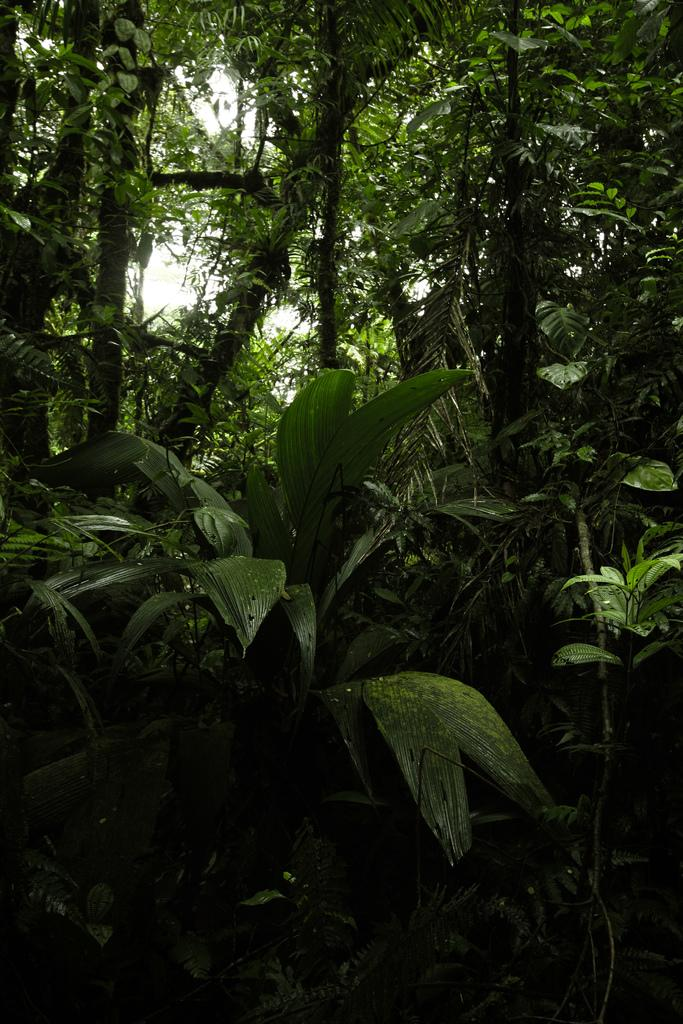What type of vegetation is present in the image? There is a group of plants and trees in the image. What can be seen in the background of the image? The sky is visible in the image. What type of turkey can be seen in the image? There is no turkey present in the image; it features a group of plants and trees. What grade is the son in the image? There is no son present in the image, as it only contains plants, trees, and the sky. 